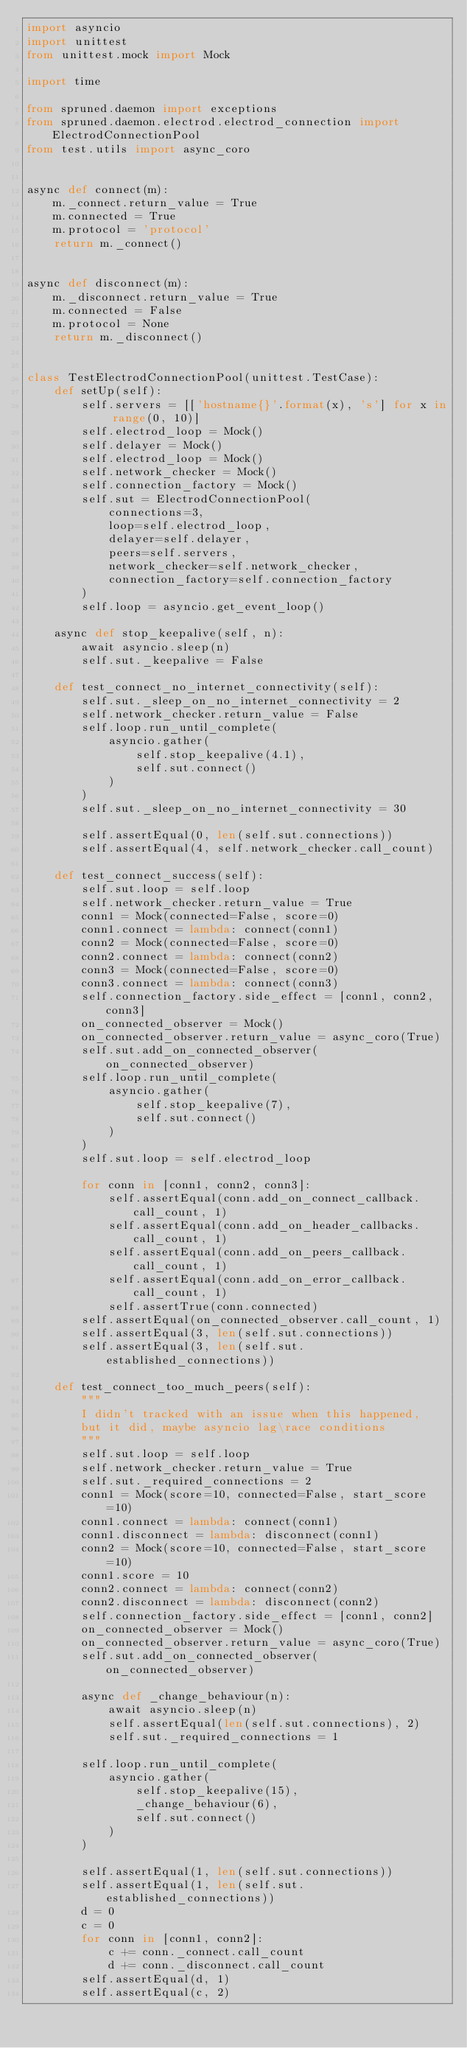Convert code to text. <code><loc_0><loc_0><loc_500><loc_500><_Python_>import asyncio
import unittest
from unittest.mock import Mock

import time

from spruned.daemon import exceptions
from spruned.daemon.electrod.electrod_connection import ElectrodConnectionPool
from test.utils import async_coro


async def connect(m):
    m._connect.return_value = True
    m.connected = True
    m.protocol = 'protocol'
    return m._connect()


async def disconnect(m):
    m._disconnect.return_value = True
    m.connected = False
    m.protocol = None
    return m._disconnect()


class TestElectrodConnectionPool(unittest.TestCase):
    def setUp(self):
        self.servers = [['hostname{}'.format(x), 's'] for x in range(0, 10)]
        self.electrod_loop = Mock()
        self.delayer = Mock()
        self.electrod_loop = Mock()
        self.network_checker = Mock()
        self.connection_factory = Mock()
        self.sut = ElectrodConnectionPool(
            connections=3,
            loop=self.electrod_loop,
            delayer=self.delayer,
            peers=self.servers,
            network_checker=self.network_checker,
            connection_factory=self.connection_factory
        )
        self.loop = asyncio.get_event_loop()

    async def stop_keepalive(self, n):
        await asyncio.sleep(n)
        self.sut._keepalive = False

    def test_connect_no_internet_connectivity(self):
        self.sut._sleep_on_no_internet_connectivity = 2
        self.network_checker.return_value = False
        self.loop.run_until_complete(
            asyncio.gather(
                self.stop_keepalive(4.1),
                self.sut.connect()
            )
        )
        self.sut._sleep_on_no_internet_connectivity = 30

        self.assertEqual(0, len(self.sut.connections))
        self.assertEqual(4, self.network_checker.call_count)

    def test_connect_success(self):
        self.sut.loop = self.loop
        self.network_checker.return_value = True
        conn1 = Mock(connected=False, score=0)
        conn1.connect = lambda: connect(conn1)
        conn2 = Mock(connected=False, score=0)
        conn2.connect = lambda: connect(conn2)
        conn3 = Mock(connected=False, score=0)
        conn3.connect = lambda: connect(conn3)
        self.connection_factory.side_effect = [conn1, conn2, conn3]
        on_connected_observer = Mock()
        on_connected_observer.return_value = async_coro(True)
        self.sut.add_on_connected_observer(on_connected_observer)
        self.loop.run_until_complete(
            asyncio.gather(
                self.stop_keepalive(7),
                self.sut.connect()
            )
        )
        self.sut.loop = self.electrod_loop

        for conn in [conn1, conn2, conn3]:
            self.assertEqual(conn.add_on_connect_callback.call_count, 1)
            self.assertEqual(conn.add_on_header_callbacks.call_count, 1)
            self.assertEqual(conn.add_on_peers_callback.call_count, 1)
            self.assertEqual(conn.add_on_error_callback.call_count, 1)
            self.assertTrue(conn.connected)
        self.assertEqual(on_connected_observer.call_count, 1)
        self.assertEqual(3, len(self.sut.connections))
        self.assertEqual(3, len(self.sut.established_connections))

    def test_connect_too_much_peers(self):
        """
        I didn't tracked with an issue when this happened,
        but it did, maybe asyncio lag\race conditions
        """
        self.sut.loop = self.loop
        self.network_checker.return_value = True
        self.sut._required_connections = 2
        conn1 = Mock(score=10, connected=False, start_score=10)
        conn1.connect = lambda: connect(conn1)
        conn1.disconnect = lambda: disconnect(conn1)
        conn2 = Mock(score=10, connected=False, start_score=10)
        conn1.score = 10
        conn2.connect = lambda: connect(conn2)
        conn2.disconnect = lambda: disconnect(conn2)
        self.connection_factory.side_effect = [conn1, conn2]
        on_connected_observer = Mock()
        on_connected_observer.return_value = async_coro(True)
        self.sut.add_on_connected_observer(on_connected_observer)

        async def _change_behaviour(n):
            await asyncio.sleep(n)
            self.assertEqual(len(self.sut.connections), 2)
            self.sut._required_connections = 1

        self.loop.run_until_complete(
            asyncio.gather(
                self.stop_keepalive(15),
                _change_behaviour(6),
                self.sut.connect()
            )
        )

        self.assertEqual(1, len(self.sut.connections))
        self.assertEqual(1, len(self.sut.established_connections))
        d = 0
        c = 0
        for conn in [conn1, conn2]:
            c += conn._connect.call_count
            d += conn._disconnect.call_count
        self.assertEqual(d, 1)
        self.assertEqual(c, 2)</code> 